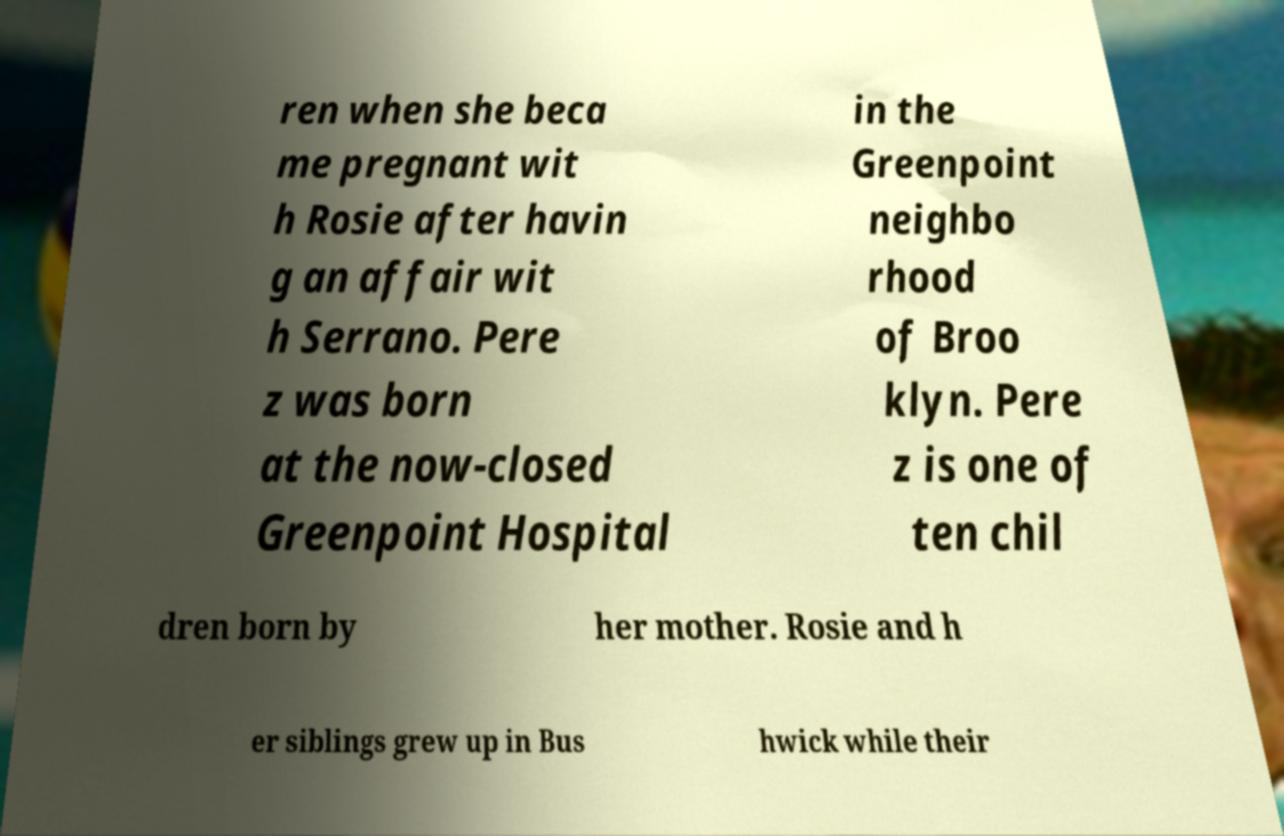Can you read and provide the text displayed in the image?This photo seems to have some interesting text. Can you extract and type it out for me? ren when she beca me pregnant wit h Rosie after havin g an affair wit h Serrano. Pere z was born at the now-closed Greenpoint Hospital in the Greenpoint neighbo rhood of Broo klyn. Pere z is one of ten chil dren born by her mother. Rosie and h er siblings grew up in Bus hwick while their 